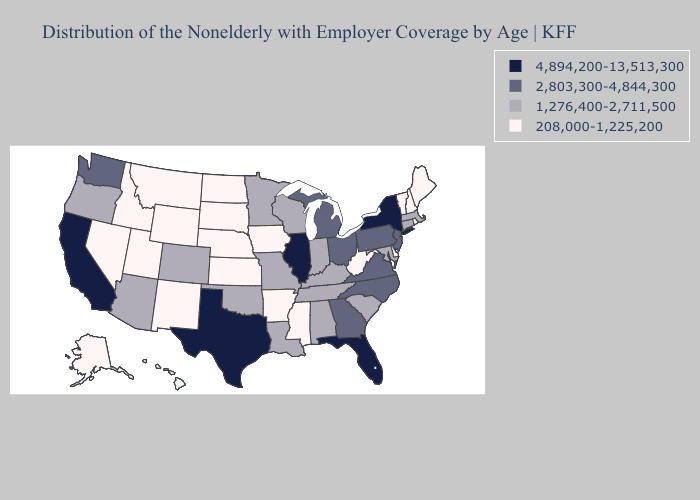Does Missouri have the lowest value in the USA?
Write a very short answer. No. What is the lowest value in the Northeast?
Answer briefly. 208,000-1,225,200. Among the states that border Iowa , does Wisconsin have the highest value?
Be succinct. No. Among the states that border Arkansas , which have the lowest value?
Write a very short answer. Mississippi. Name the states that have a value in the range 208,000-1,225,200?
Quick response, please. Alaska, Arkansas, Delaware, Hawaii, Idaho, Iowa, Kansas, Maine, Mississippi, Montana, Nebraska, Nevada, New Hampshire, New Mexico, North Dakota, Rhode Island, South Dakota, Utah, Vermont, West Virginia, Wyoming. Which states hav the highest value in the Northeast?
Write a very short answer. New York. Does New Hampshire have the lowest value in the USA?
Short answer required. Yes. What is the value of Ohio?
Keep it brief. 2,803,300-4,844,300. Name the states that have a value in the range 2,803,300-4,844,300?
Quick response, please. Georgia, Michigan, New Jersey, North Carolina, Ohio, Pennsylvania, Virginia, Washington. What is the highest value in the South ?
Quick response, please. 4,894,200-13,513,300. What is the highest value in the Northeast ?
Quick response, please. 4,894,200-13,513,300. Name the states that have a value in the range 2,803,300-4,844,300?
Keep it brief. Georgia, Michigan, New Jersey, North Carolina, Ohio, Pennsylvania, Virginia, Washington. Among the states that border West Virginia , does Virginia have the highest value?
Give a very brief answer. Yes. What is the value of Alaska?
Be succinct. 208,000-1,225,200. Which states have the lowest value in the South?
Short answer required. Arkansas, Delaware, Mississippi, West Virginia. 